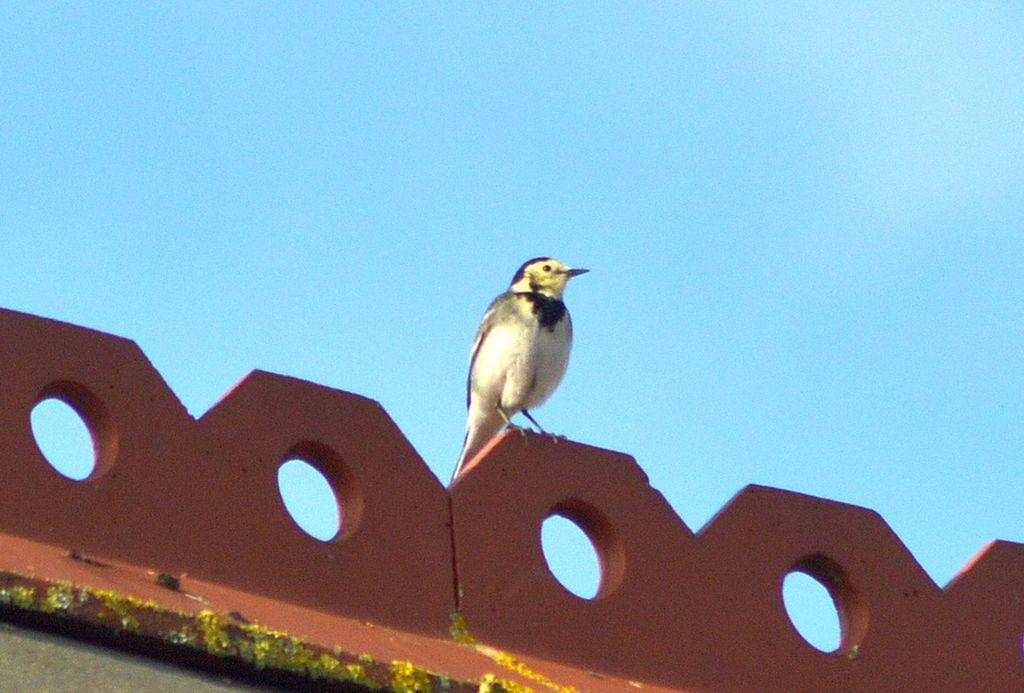What type of animal is in the image? There is a bird in the image. Can you describe the coloration of the bird? The bird has white and black coloration. What can be seen in the background of the image? There is sky visible in the background of the image. What color is present in the image besides the bird's coloration? There are green color things in the image. Where is the beast hiding in the image? There is no beast present in the image; it only features a bird. What direction is the bird pointing in the image? The bird's orientation cannot be determined from the image, as it is not shown in motion or facing a specific direction. 